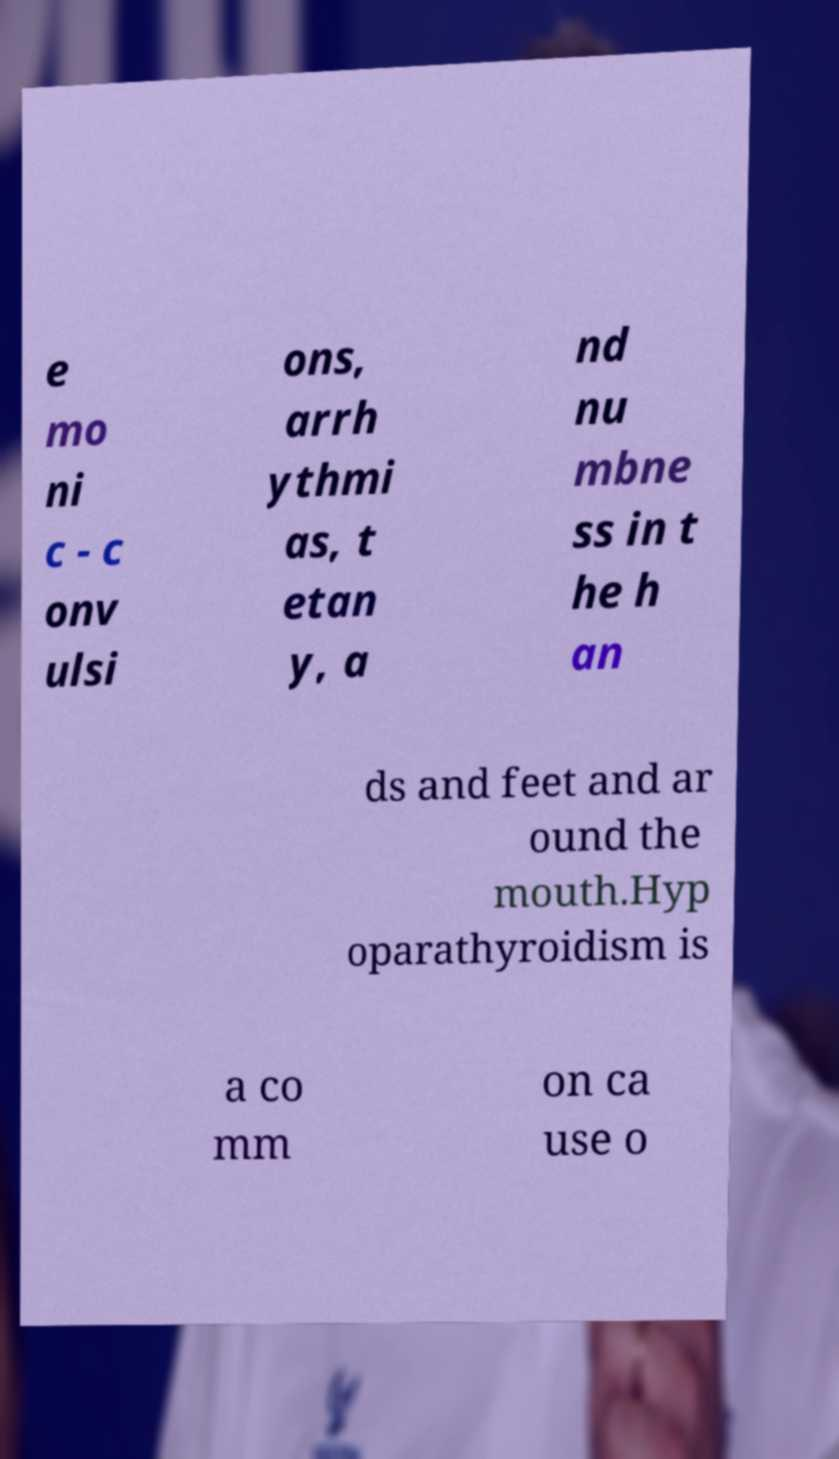What messages or text are displayed in this image? I need them in a readable, typed format. e mo ni c - c onv ulsi ons, arrh ythmi as, t etan y, a nd nu mbne ss in t he h an ds and feet and ar ound the mouth.Hyp oparathyroidism is a co mm on ca use o 